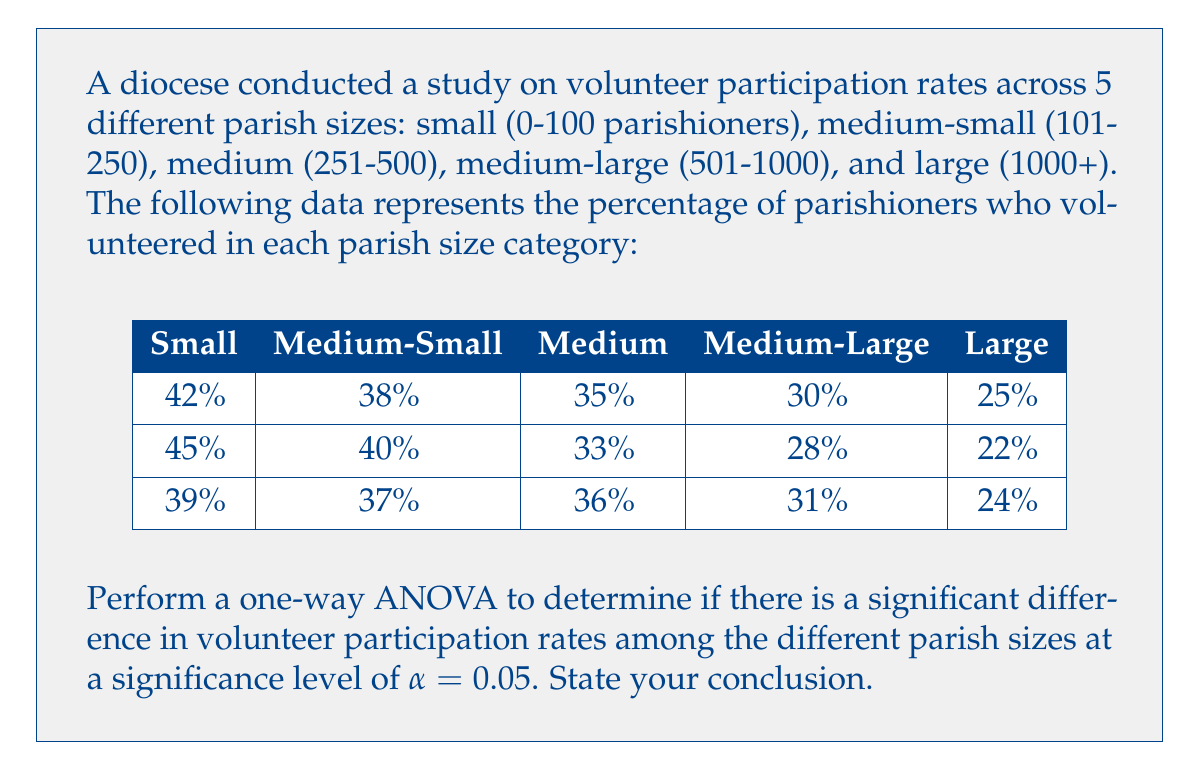Can you answer this question? Let's perform the one-way ANOVA step-by-step:

1) Calculate the overall mean:
   $\bar{X} = \frac{42 + 45 + 39 + 38 + 40 + 37 + 35 + 33 + 36 + 30 + 28 + 31 + 25 + 22 + 24}{15} = 33.67\%$

2) Calculate the sum of squares total (SST):
   $SST = \sum(X - \bar{X})^2 = 840.67$

3) Calculate the sum of squares between groups (SSB):
   $SSB = n_1(\bar{X}_1 - \bar{X})^2 + n_2(\bar{X}_2 - \bar{X})^2 + ... + n_5(\bar{X}_5 - \bar{X})^2$
   $SSB = 3(42 - 33.67)^2 + 3(38.33 - 33.67)^2 + 3(34.67 - 33.67)^2 + 3(29.67 - 33.67)^2 + 3(23.67 - 33.67)^2$
   $SSB = 816.67$

4) Calculate the sum of squares within groups (SSW):
   $SSW = SST - SSB = 840.67 - 816.67 = 24$

5) Degrees of freedom:
   $df_{between} = k - 1 = 5 - 1 = 4$
   $df_{within} = N - k = 15 - 5 = 10$
   $df_{total} = N - 1 = 15 - 1 = 14$

6) Mean squares:
   $MS_{between} = \frac{SSB}{df_{between}} = \frac{816.67}{4} = 204.17$
   $MS_{within} = \frac{SSW}{df_{within}} = \frac{24}{10} = 2.4$

7) F-statistic:
   $F = \frac{MS_{between}}{MS_{within}} = \frac{204.17}{2.4} = 85.07$

8) Critical F-value:
   For $\alpha = 0.05$, $df_{between} = 4$, and $df_{within} = 10$, the critical F-value is approximately 3.48.

9) Decision:
   Since $85.07 > 3.48$, we reject the null hypothesis.

Conclusion: There is significant evidence to conclude that there are differences in volunteer participation rates among the different parish sizes at the 0.05 significance level.
Answer: Reject null hypothesis; significant differences exist in volunteer rates among parish sizes (F = 85.07, p < 0.05). 